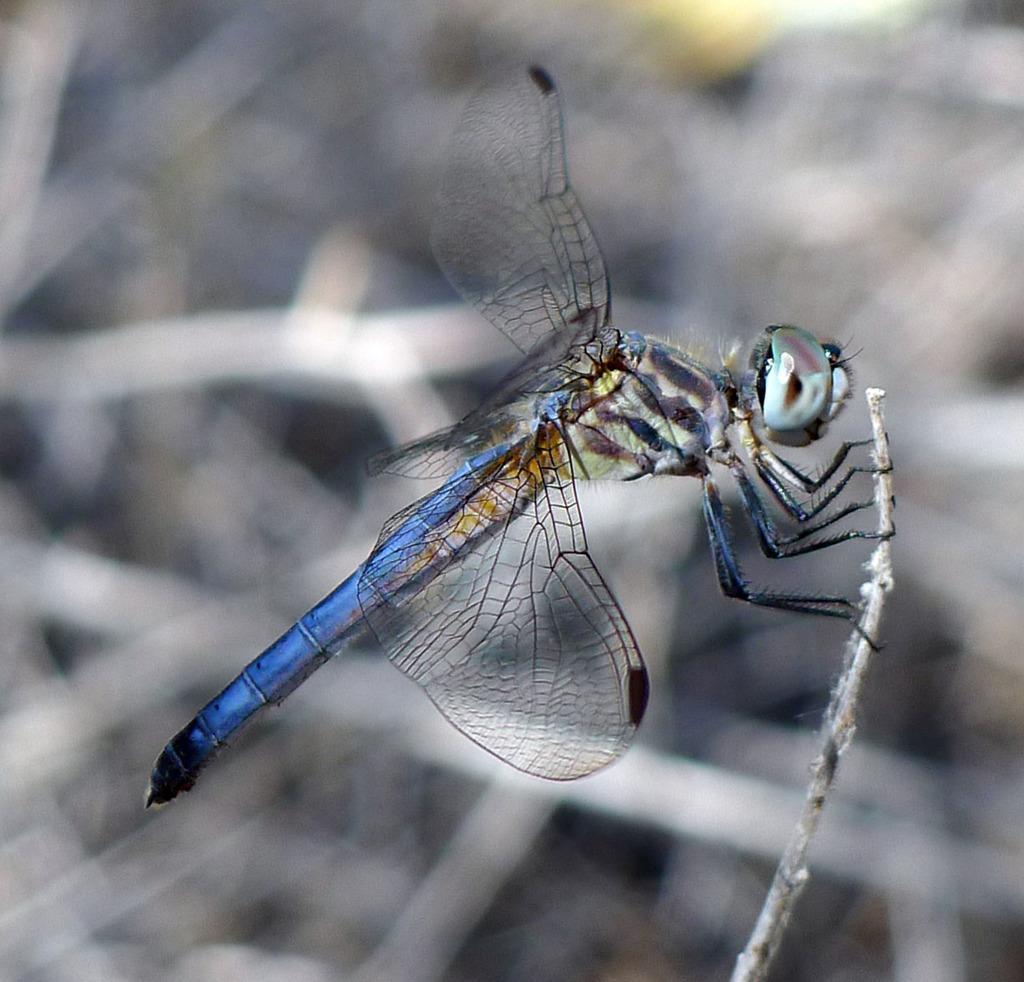Please provide a concise description of this image. This image is taken outdoors. In this image the background is blurred. In the middle of the image there is a dragonfly on the stem. 